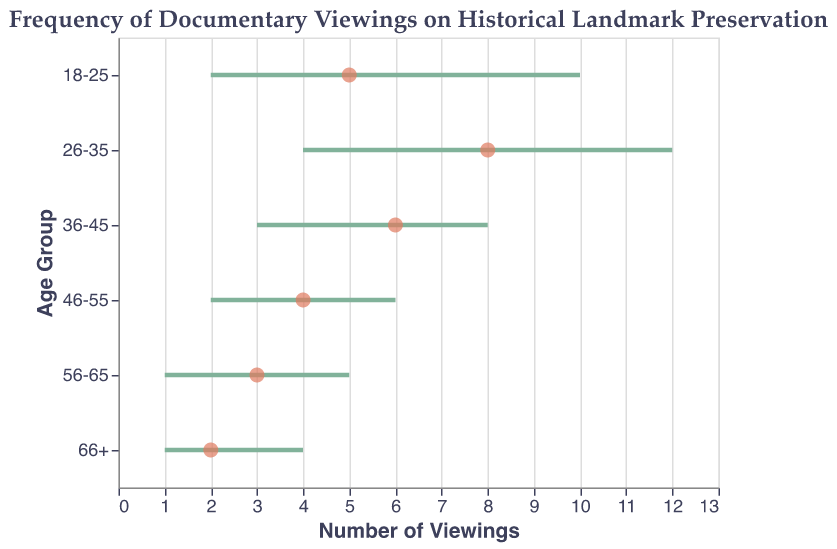What is the title of the figure? The title is displayed at the top of the figure and reads, "Frequency of Documentary Viewings on Historical Landmark Preservation."
Answer: Frequency of Documentary Viewings on Historical Landmark Preservation Which age group has the highest maximum number of viewings? The maximum number of viewings is the rightmost point on the horizontal axis for each age group range. The age group 26-35 has the highest maximum viewings at 12.
Answer: 26-35 What is the most common number of viewings for the 36-45 age group? The most common number of viewings is represented by the filled circles in the plot. For the 36-45 age group, the most common viewing is marked at 6.
Answer: 6 What is the range of viewings for the 56-65 age group? The range is given by the span between the minimum and maximum viewings. For the 56-65 age group, the range extends from 1 to 5.
Answer: 1 to 5 Compare the most common viewings of the 18-25 and 46-55 age groups. Which one is higher? The filled circles indicate the most common number of viewings. The 18-25 age group has a most common viewing of 5, while the 46-55 age group has a most common viewing of 4. Thus, 18-25 is higher.
Answer: 18-25 Which age group has the smallest range of viewings? To find the smallest range, subtract the minimum viewings from the maximum viewings for each age group and identify the smallest difference. The 66+ age group has a range from 1 to 4, which is the smallest range (3).
Answer: 66+ Which age group has a minimum number of viewings that exceeds the maximum number of viewings of the 66+ age group? The maximum number of viewings for the 66+ age group is 4. Next, check each age group to see whose minimum number of viewings is greater than 4. Only the 26-35 age group has a minimum of 4, which matches but does not exceed. Therefore, no age group exceeds.
Answer: None What's the difference between the most common viewings of the 26-35 and 56-65 age groups? The most common viewings for 26-35 and 56-65 are marked at 8 and 3, respectively. The difference is calculated as 8 - 3 = 5.
Answer: 5 Identify the age group whose minimum viewings are equal to their most common viewings. Check each age group to see if the minimum viewings equal the most common viewings. The 66+ age group has both minimum and most common viewings equal to 2.
Answer: 66+ Which age group has the widest range of viewings? To find the widest range, compute the range (Max_Viewings - Min_Viewings) for each age group. The 26-35 age group has a range of 12 - 4 = 8, which is the widest range.
Answer: 26-35 